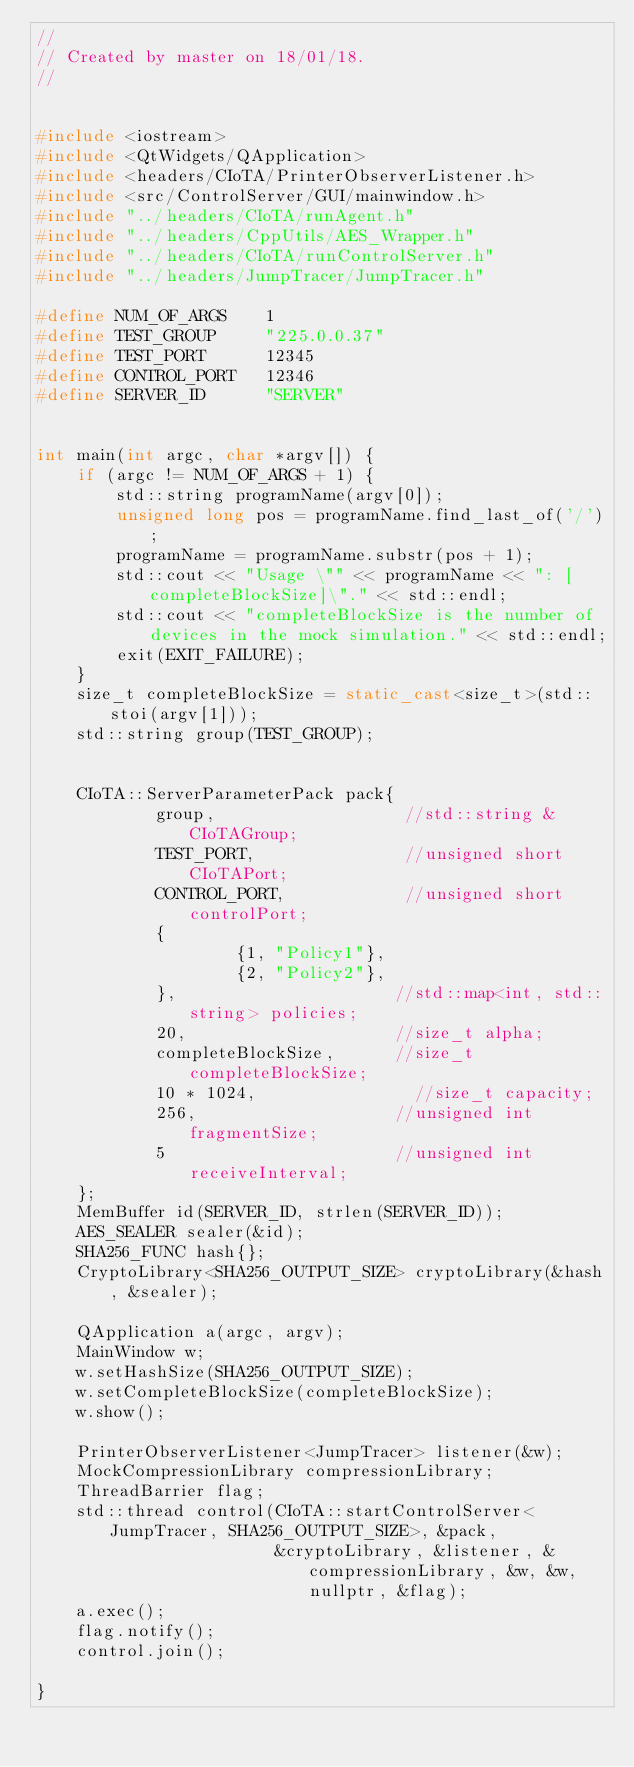Convert code to text. <code><loc_0><loc_0><loc_500><loc_500><_C++_>//
// Created by master on 18/01/18.
//


#include <iostream>
#include <QtWidgets/QApplication>
#include <headers/CIoTA/PrinterObserverListener.h>
#include <src/ControlServer/GUI/mainwindow.h>
#include "../headers/CIoTA/runAgent.h"
#include "../headers/CppUtils/AES_Wrapper.h"
#include "../headers/CIoTA/runControlServer.h"
#include "../headers/JumpTracer/JumpTracer.h"

#define NUM_OF_ARGS    1
#define TEST_GROUP     "225.0.0.37"
#define TEST_PORT      12345
#define CONTROL_PORT   12346
#define SERVER_ID      "SERVER"


int main(int argc, char *argv[]) {
    if (argc != NUM_OF_ARGS + 1) {
        std::string programName(argv[0]);
        unsigned long pos = programName.find_last_of('/');
        programName = programName.substr(pos + 1);
        std::cout << "Usage \"" << programName << ": [completeBlockSize]\"." << std::endl;
        std::cout << "completeBlockSize is the number of devices in the mock simulation." << std::endl;
        exit(EXIT_FAILURE);
    }
    size_t completeBlockSize = static_cast<size_t>(std::stoi(argv[1]));
    std::string group(TEST_GROUP);


    CIoTA::ServerParameterPack pack{
            group,                   //std::string &CIoTAGroup;
            TEST_PORT,               //unsigned short CIoTAPort;
            CONTROL_PORT,            //unsigned short controlPort;
            {
                    {1, "Policy1"},
                    {2, "Policy2"},
            },                      //std::map<int, std::string> policies;
            20,                     //size_t alpha;
            completeBlockSize,      //size_t completeBlockSize;
            10 * 1024,                //size_t capacity;
            256,                    //unsigned int fragmentSize;
            5                       //unsigned int receiveInterval;
    };
    MemBuffer id(SERVER_ID, strlen(SERVER_ID));
    AES_SEALER sealer(&id);
    SHA256_FUNC hash{};
    CryptoLibrary<SHA256_OUTPUT_SIZE> cryptoLibrary(&hash, &sealer);

    QApplication a(argc, argv);
    MainWindow w;
    w.setHashSize(SHA256_OUTPUT_SIZE);
    w.setCompleteBlockSize(completeBlockSize);
    w.show();

    PrinterObserverListener<JumpTracer> listener(&w);
    MockCompressionLibrary compressionLibrary;
    ThreadBarrier flag;
    std::thread control(CIoTA::startControlServer<JumpTracer, SHA256_OUTPUT_SIZE>, &pack,
                        &cryptoLibrary, &listener, &compressionLibrary, &w, &w, nullptr, &flag);
    a.exec();
    flag.notify();
    control.join();

}</code> 